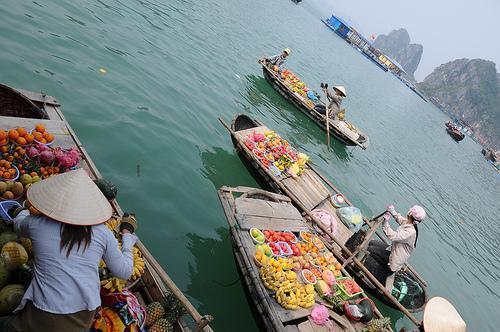How many people are in this picture?
Give a very brief answer. 4. 